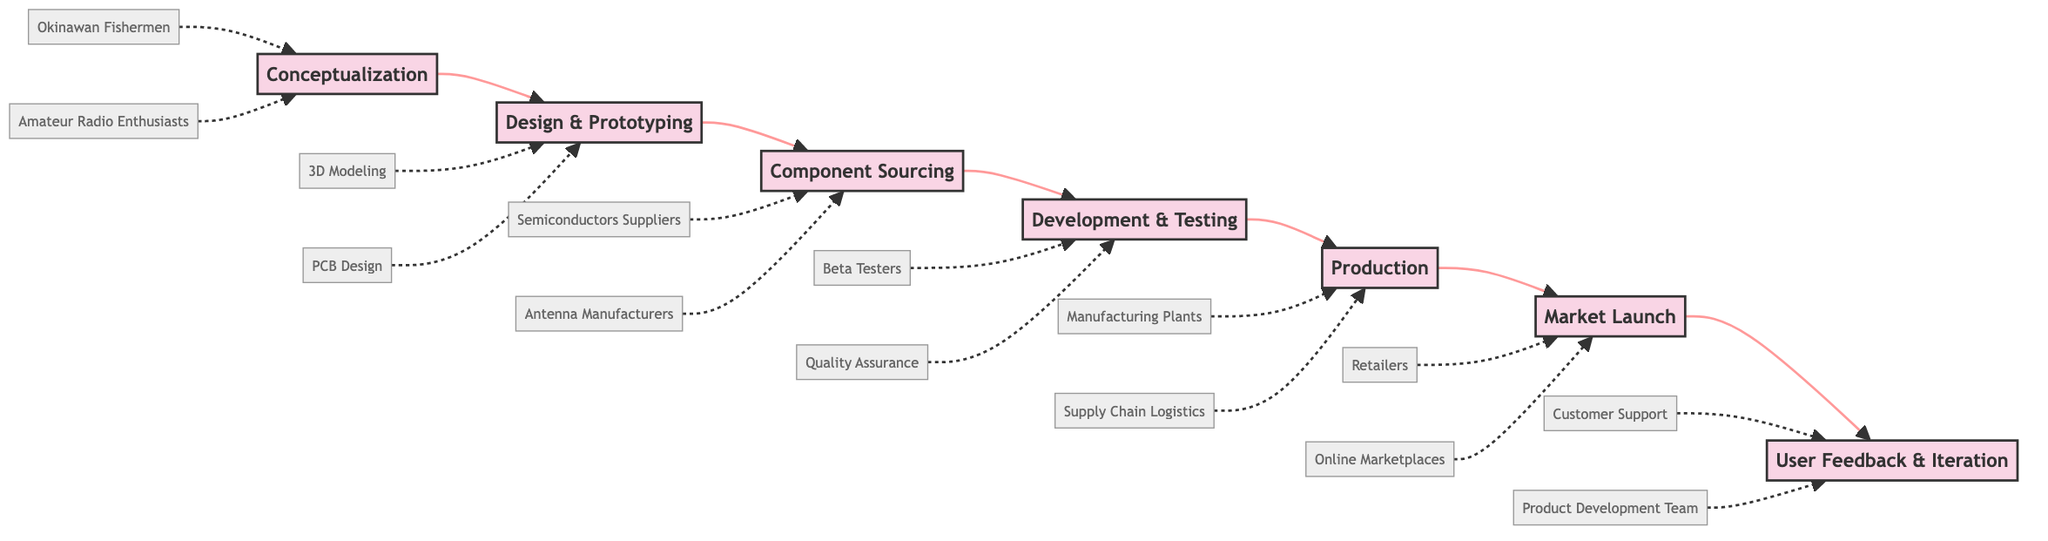What is the first stage described in the flowchart? The flowchart indicates that the first stage is labeled "Conceptualization." Since it appears at the beginning of the horizontal flow from A to G, it is directly identifiable as the initial point.
Answer: Conceptualization How many stages are there in total according to the flowchart? To find the total number of stages, we can count each distinct labeled box in the diagram from A to G. There are seven stages listed, indicating a total of 7.
Answer: 7 Which stage follows "Development & Testing"? The diagram clearly shows that "Production" directly follows the "Development & Testing" stage in the flow. Therefore, by tracing the arrows, we find that "Production" comes next.
Answer: Production Who influenced the "Conceptualization" stage? Within the description of the "Conceptualization" stage, we note that it mentions "Okinawan Fishermen" and "Amateur Radio Enthusiasts" as key entities, both impacting this initial thought process.
Answer: Okinawan Fishermen, Amateur Radio Enthusiasts What action is taken during the "User Feedback & Iteration" stage? The description for the "User Feedback & Iteration" stage indicates the action of "Collecting user feedback and making necessary improvements and iterations." This shows the purpose of the stage very clearly.
Answer: Collecting user feedback and making necessary improvements and iterations What is the relationship between "Design & Prototyping" and "Component Sourcing"? The flowchart shows a direct arrow from the "Design & Prototyping" stage to the "Component Sourcing" stage, indicating a sequential relationship where design precedes sourcing of components, making it a straightforward flow.
Answer: Sequential relationship Which key entities are part of the "Production" stage? The entities associated with the "Production" stage are specified as "Manufacturing Plants" and "Supply Chain Logistics." Thus, they directly relate to the processes involved in this stage.
Answer: Manufacturing Plants, Supply Chain Logistics In which stage is beta testing involved? The "Development & Testing" stage includes "Beta Testers" as one of its key entities, pointing out that this is when beta testing occurs within the overall flow of development.
Answer: Development & Testing Which stage is prior to "Market Launch"? From examining the flowchart, we can see that "Production" precedes the "Market Launch" stage, indicating the necessary development and manufacturing steps before launching into the market.
Answer: Production 